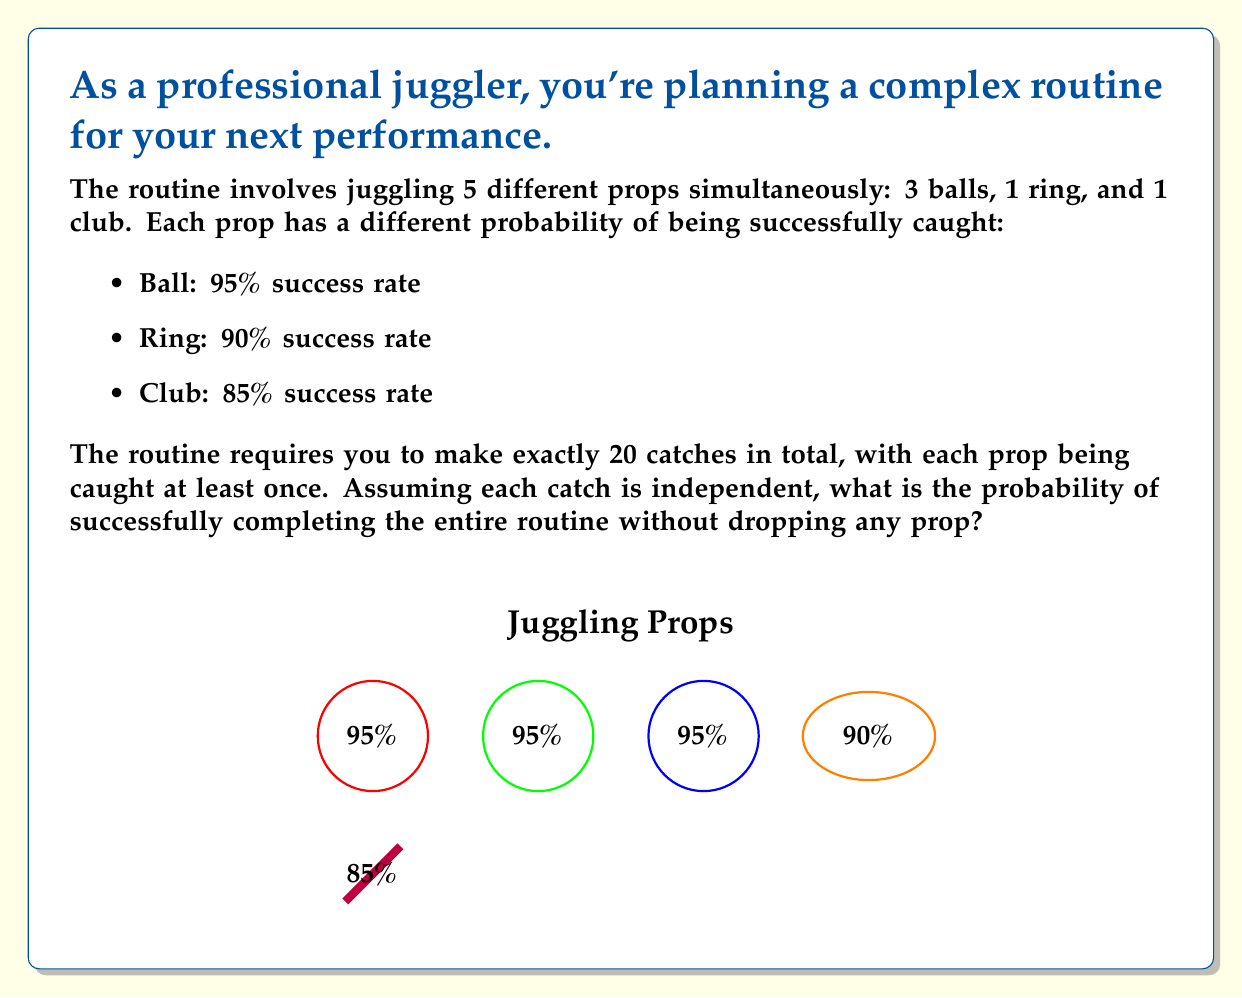Help me with this question. Let's approach this step-by-step:

1) First, we need to calculate the probability of catching each type of prop at least once:

   For balls: $P(\text{at least one ball}) = 1 - (0.05)^3 = 0.999875$
   For ring: $P(\text{ring}) = 0.90$
   For club: $P(\text{club}) = 0.85$

2) Now, we need to consider the remaining 15 catches (since 5 catches are accounted for above). These can be any combination of the props. The probability of a successful catch for any prop is:

   $P(\text{any catch}) = \frac{3(0.95) + 0.90 + 0.85}{5} = 0.92$

3) The probability of successfully making all 15 remaining catches is:

   $P(\text{15 catches}) = (0.92)^{15} = 0.2877$

4) Now, we can combine all these probabilities:

   $P(\text{entire routine}) = 0.999875 \times 0.90 \times 0.85 \times 0.2877$

5) Calculating this:

   $P(\text{entire routine}) = 0.220675 \approx 0.2207$

Therefore, the probability of successfully completing the entire routine is approximately 0.2207 or 22.07%.
Answer: $0.2207$ or $22.07\%$ 